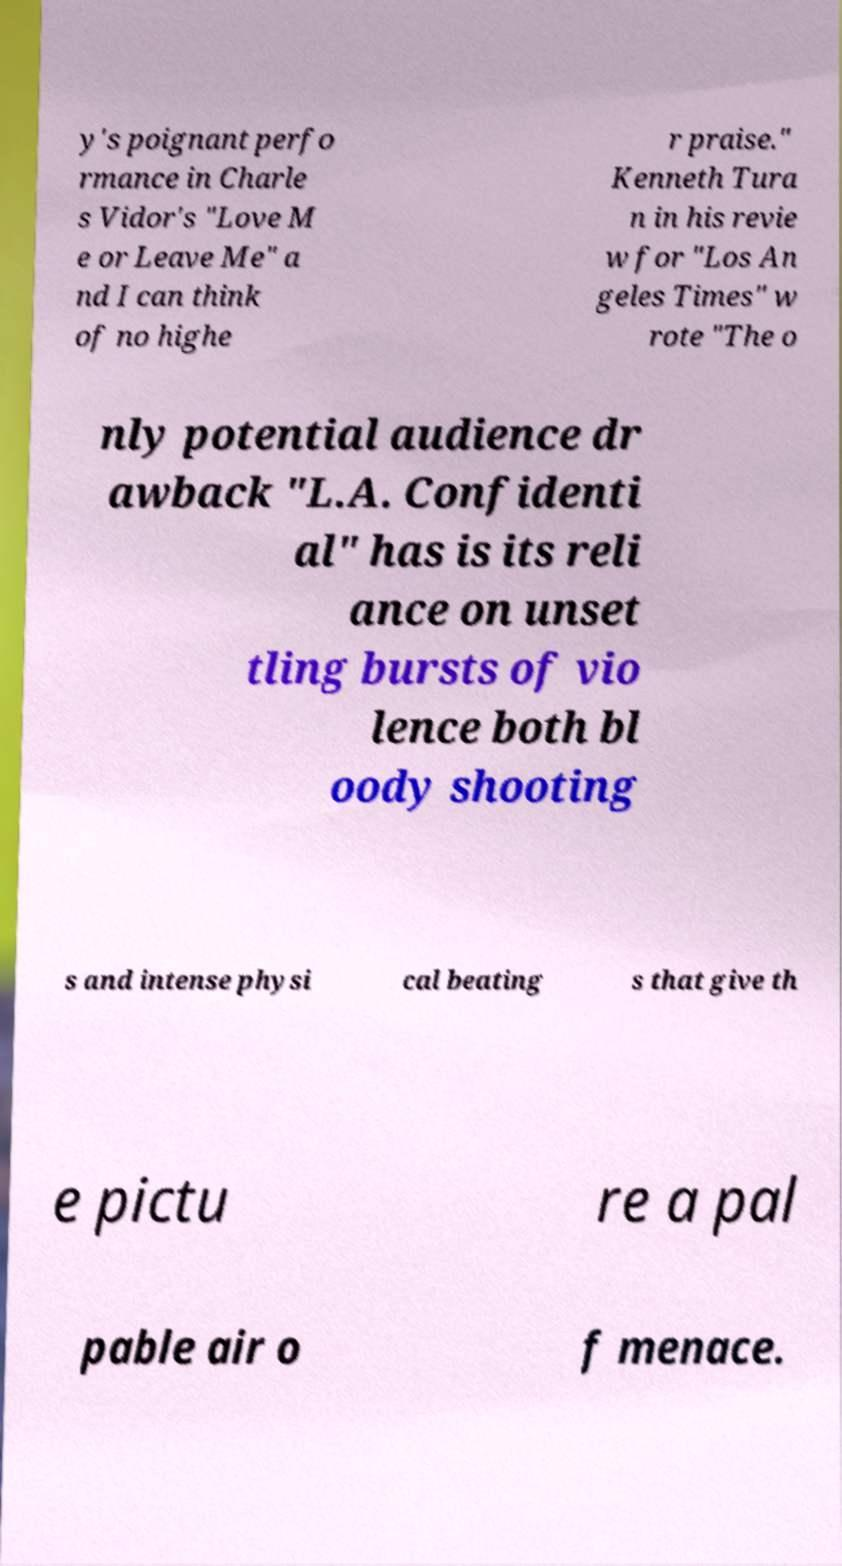For documentation purposes, I need the text within this image transcribed. Could you provide that? y's poignant perfo rmance in Charle s Vidor's "Love M e or Leave Me" a nd I can think of no highe r praise." Kenneth Tura n in his revie w for "Los An geles Times" w rote "The o nly potential audience dr awback "L.A. Confidenti al" has is its reli ance on unset tling bursts of vio lence both bl oody shooting s and intense physi cal beating s that give th e pictu re a pal pable air o f menace. 